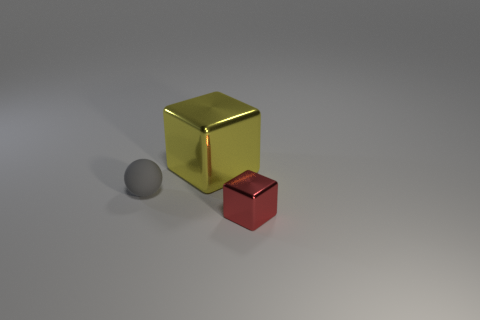Are the big yellow object and the tiny red object made of the same material? While the original yes/no response was concise, it lacked context. Based on the visual cues, the big yellow object and the tiny red object appear to have different shades and reflections, indicating that they might be made of different types of materials. The yellow object has a bright, metallic sheen which suggests that it could be made of a polished metal, possibly gold-colored. On the other hand, the red object has a less reflective surface which could imply a matte paint finish, possibly over plastic or metal. Without tactile examination or further details, we can't be certain, but their visual properties suggest that they're not made out of the same material. 